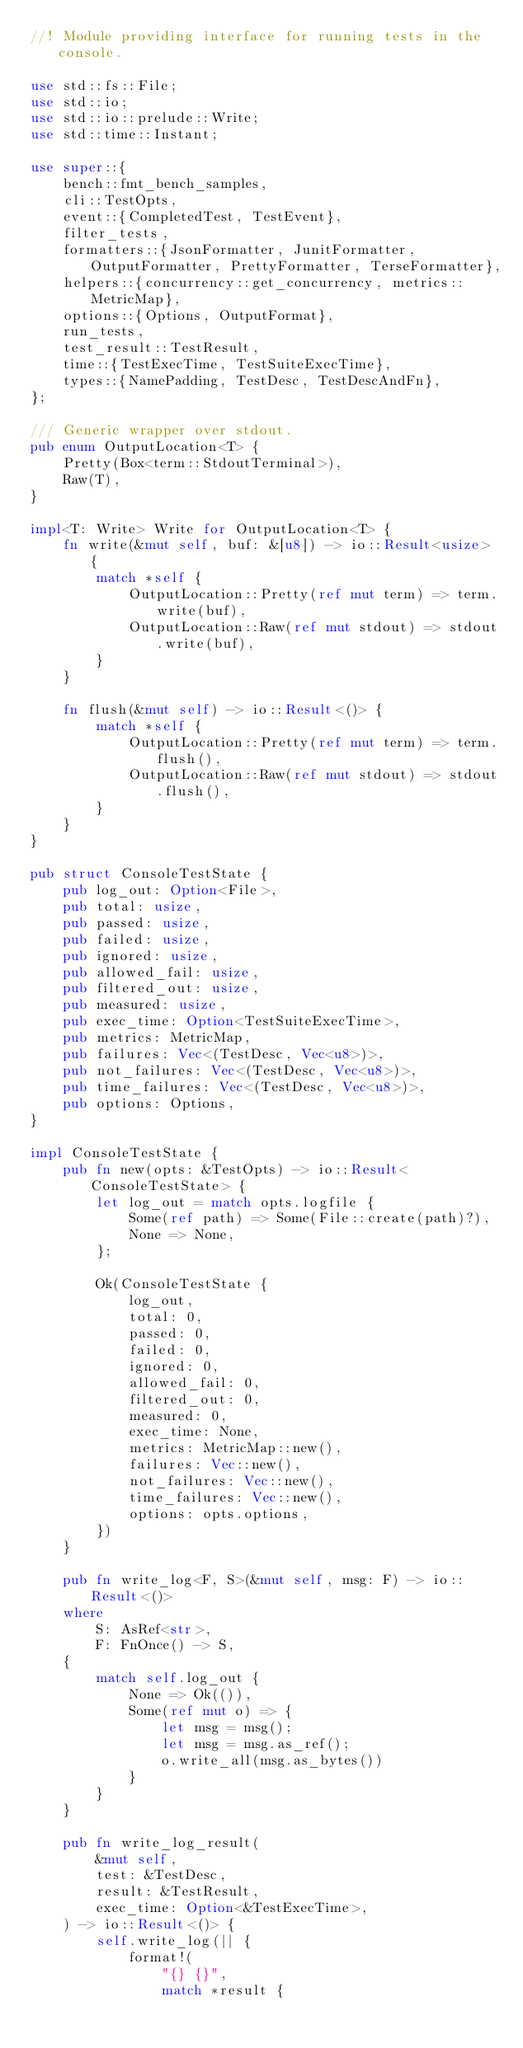<code> <loc_0><loc_0><loc_500><loc_500><_Rust_>//! Module providing interface for running tests in the console.

use std::fs::File;
use std::io;
use std::io::prelude::Write;
use std::time::Instant;

use super::{
    bench::fmt_bench_samples,
    cli::TestOpts,
    event::{CompletedTest, TestEvent},
    filter_tests,
    formatters::{JsonFormatter, JunitFormatter, OutputFormatter, PrettyFormatter, TerseFormatter},
    helpers::{concurrency::get_concurrency, metrics::MetricMap},
    options::{Options, OutputFormat},
    run_tests,
    test_result::TestResult,
    time::{TestExecTime, TestSuiteExecTime},
    types::{NamePadding, TestDesc, TestDescAndFn},
};

/// Generic wrapper over stdout.
pub enum OutputLocation<T> {
    Pretty(Box<term::StdoutTerminal>),
    Raw(T),
}

impl<T: Write> Write for OutputLocation<T> {
    fn write(&mut self, buf: &[u8]) -> io::Result<usize> {
        match *self {
            OutputLocation::Pretty(ref mut term) => term.write(buf),
            OutputLocation::Raw(ref mut stdout) => stdout.write(buf),
        }
    }

    fn flush(&mut self) -> io::Result<()> {
        match *self {
            OutputLocation::Pretty(ref mut term) => term.flush(),
            OutputLocation::Raw(ref mut stdout) => stdout.flush(),
        }
    }
}

pub struct ConsoleTestState {
    pub log_out: Option<File>,
    pub total: usize,
    pub passed: usize,
    pub failed: usize,
    pub ignored: usize,
    pub allowed_fail: usize,
    pub filtered_out: usize,
    pub measured: usize,
    pub exec_time: Option<TestSuiteExecTime>,
    pub metrics: MetricMap,
    pub failures: Vec<(TestDesc, Vec<u8>)>,
    pub not_failures: Vec<(TestDesc, Vec<u8>)>,
    pub time_failures: Vec<(TestDesc, Vec<u8>)>,
    pub options: Options,
}

impl ConsoleTestState {
    pub fn new(opts: &TestOpts) -> io::Result<ConsoleTestState> {
        let log_out = match opts.logfile {
            Some(ref path) => Some(File::create(path)?),
            None => None,
        };

        Ok(ConsoleTestState {
            log_out,
            total: 0,
            passed: 0,
            failed: 0,
            ignored: 0,
            allowed_fail: 0,
            filtered_out: 0,
            measured: 0,
            exec_time: None,
            metrics: MetricMap::new(),
            failures: Vec::new(),
            not_failures: Vec::new(),
            time_failures: Vec::new(),
            options: opts.options,
        })
    }

    pub fn write_log<F, S>(&mut self, msg: F) -> io::Result<()>
    where
        S: AsRef<str>,
        F: FnOnce() -> S,
    {
        match self.log_out {
            None => Ok(()),
            Some(ref mut o) => {
                let msg = msg();
                let msg = msg.as_ref();
                o.write_all(msg.as_bytes())
            }
        }
    }

    pub fn write_log_result(
        &mut self,
        test: &TestDesc,
        result: &TestResult,
        exec_time: Option<&TestExecTime>,
    ) -> io::Result<()> {
        self.write_log(|| {
            format!(
                "{} {}",
                match *result {</code> 